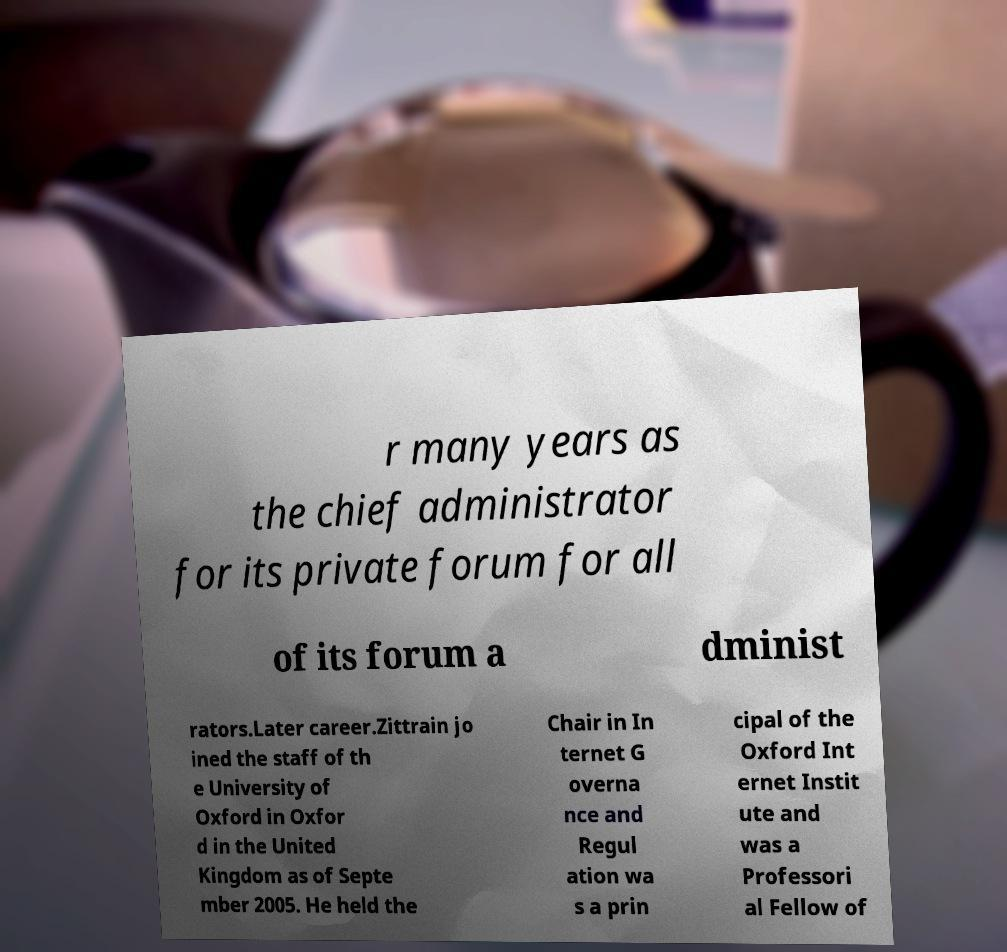I need the written content from this picture converted into text. Can you do that? r many years as the chief administrator for its private forum for all of its forum a dminist rators.Later career.Zittrain jo ined the staff of th e University of Oxford in Oxfor d in the United Kingdom as of Septe mber 2005. He held the Chair in In ternet G overna nce and Regul ation wa s a prin cipal of the Oxford Int ernet Instit ute and was a Professori al Fellow of 